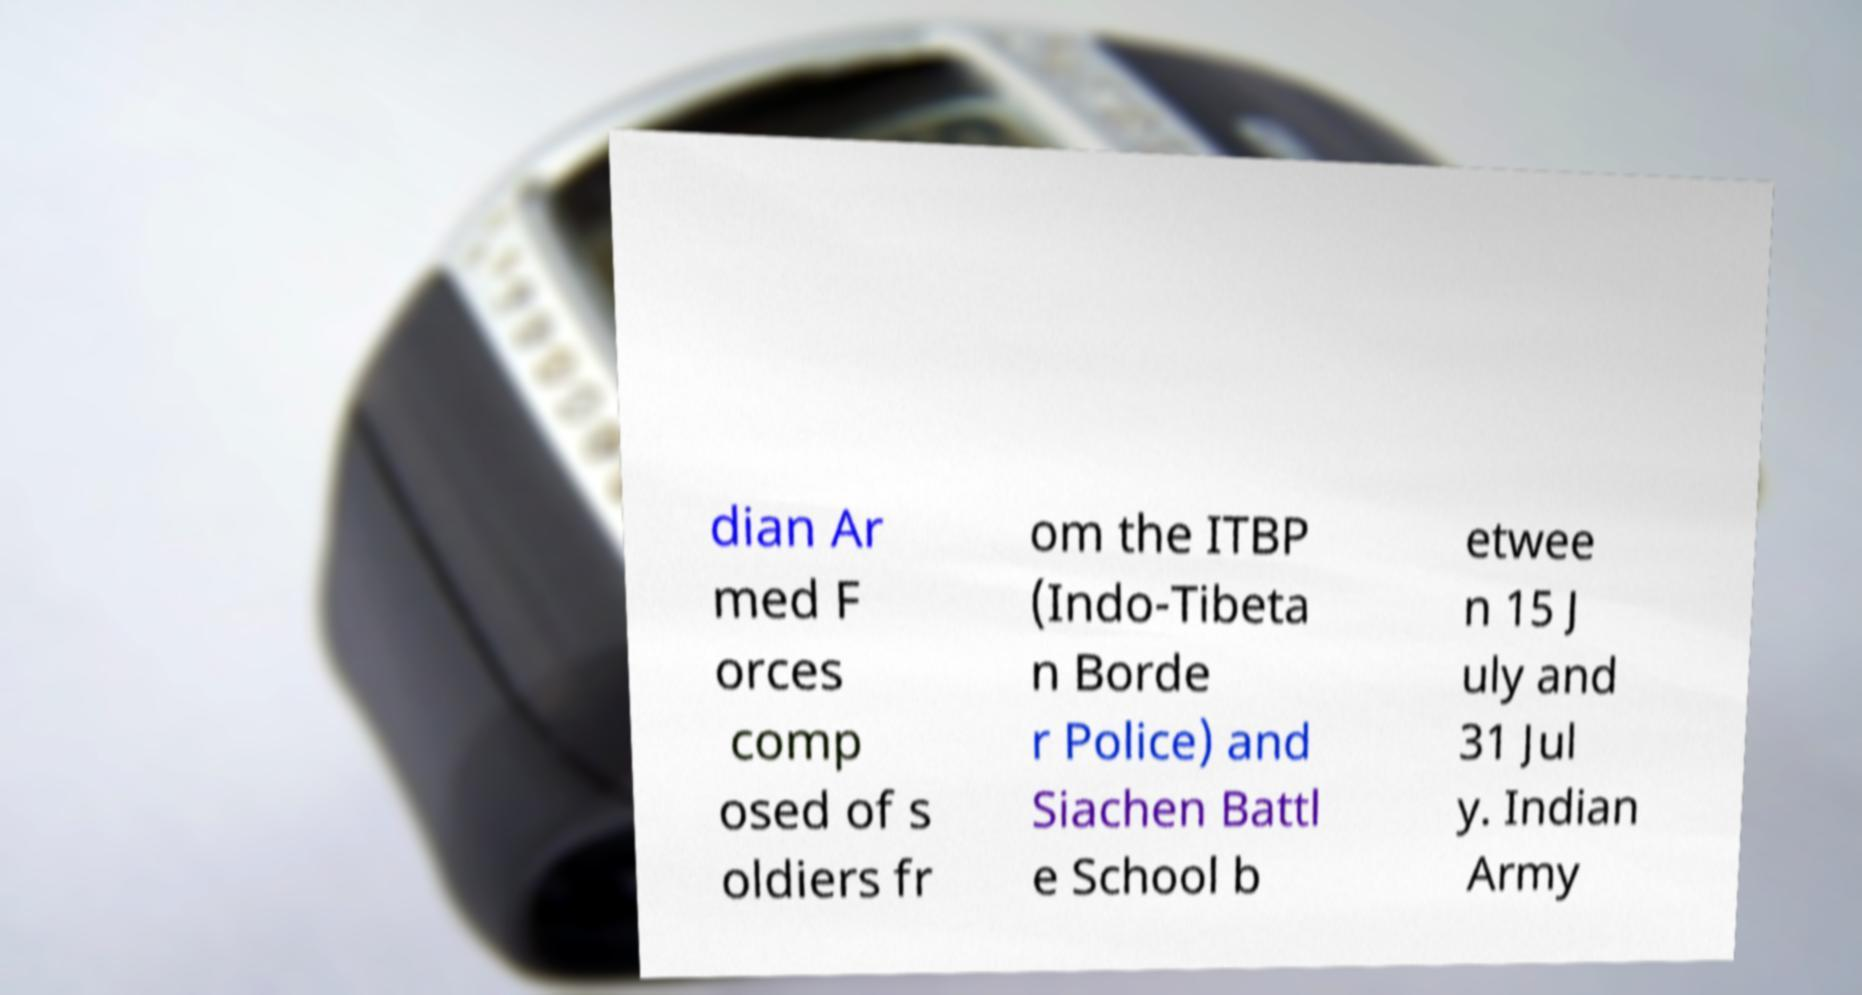Could you extract and type out the text from this image? dian Ar med F orces comp osed of s oldiers fr om the ITBP (Indo-Tibeta n Borde r Police) and Siachen Battl e School b etwee n 15 J uly and 31 Jul y. Indian Army 